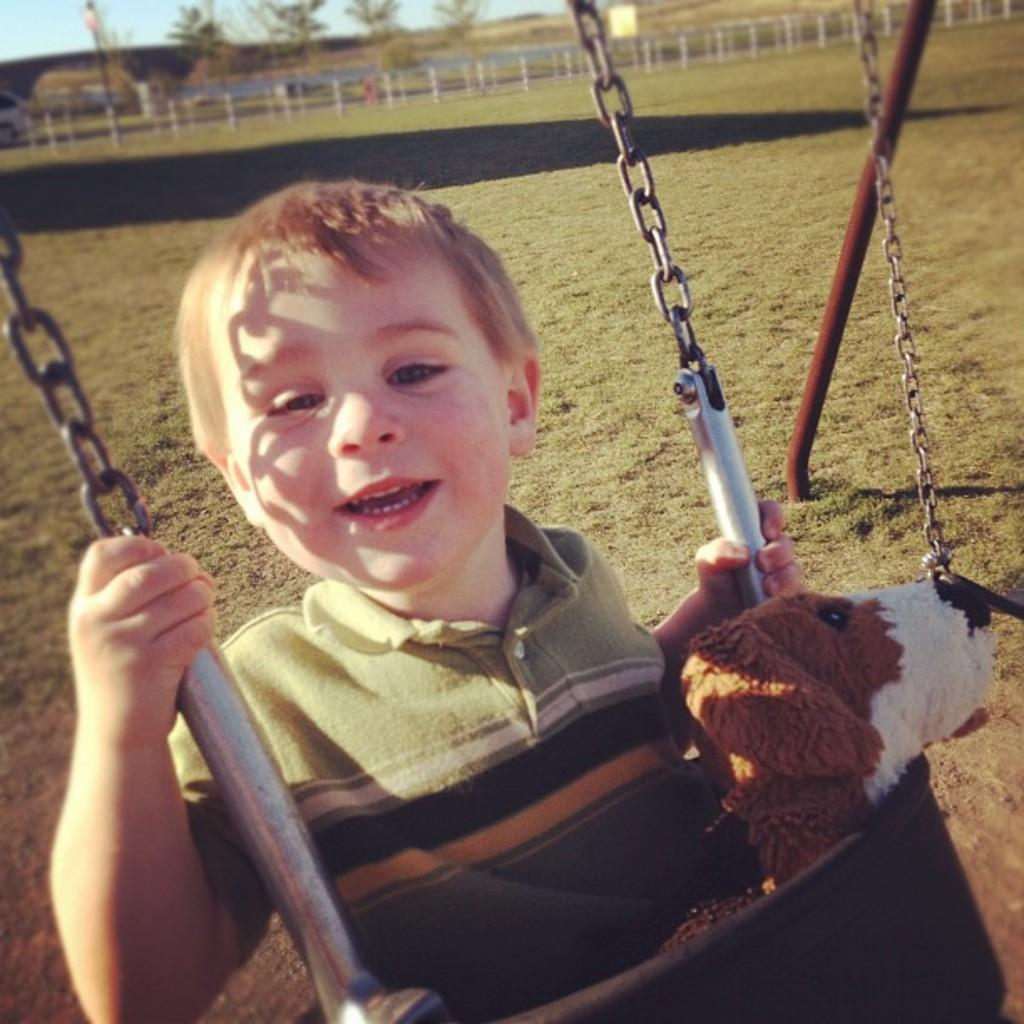What is the boy doing in the image? The boy is swinging in the image. What object is beside the boy? There is a doll beside the boy. What type of vegetation is visible at the bottom of the image? Green grass is visible at the bottom of the image. What can be seen in the background of the image? There is a fencing and trees present in the background of the image. What type of shop can be seen in the background of the image? There is no shop present in the background of the image. How many roses are visible in the image? There are no roses visible in the image. 